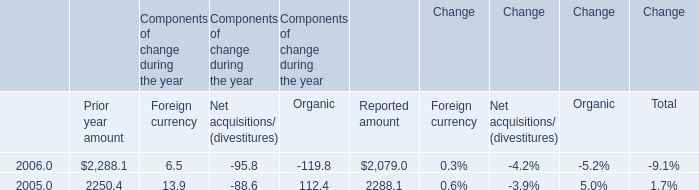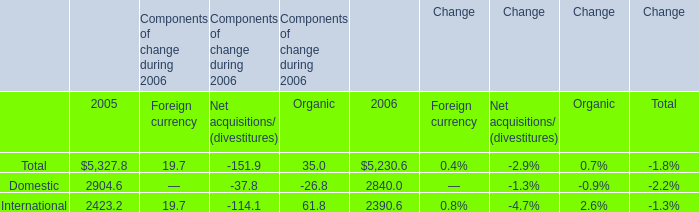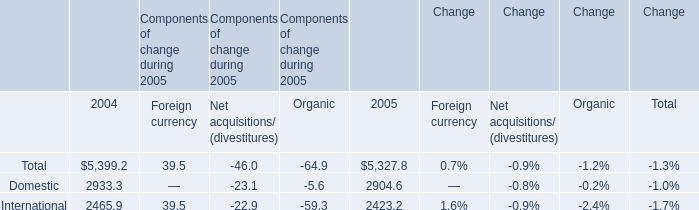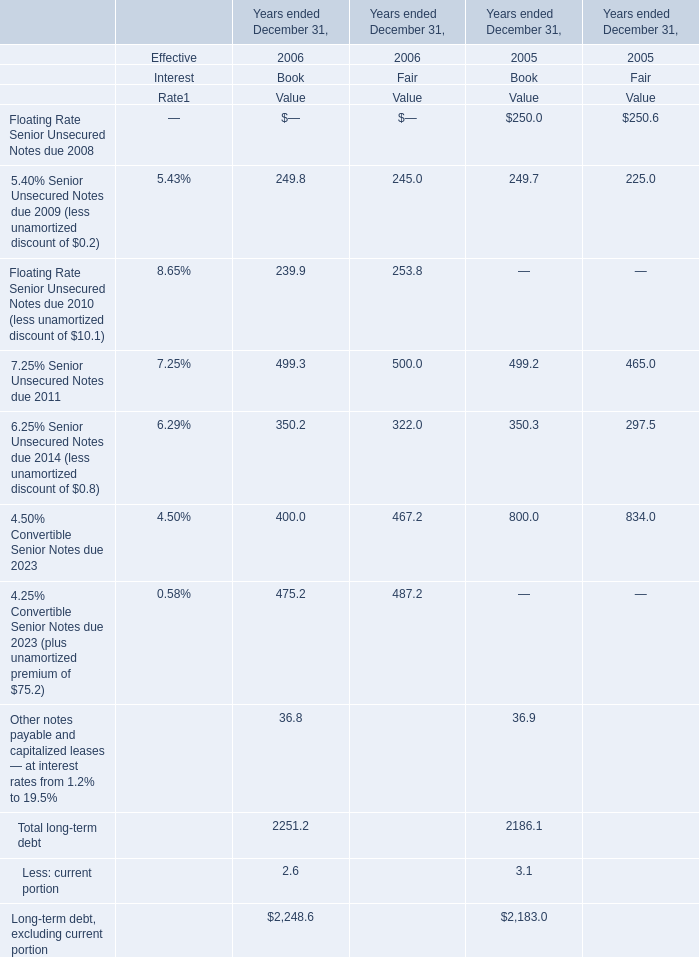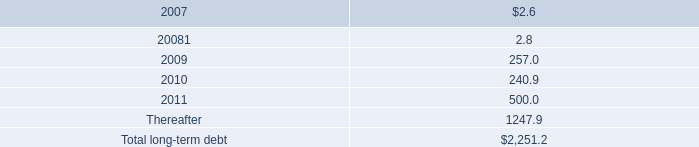what is the total interest expense incurred by the senior unsecured notes that was redeemed in august 2005? 
Computations: ((258.6 - 250.0) - 1.4)
Answer: 7.2. 